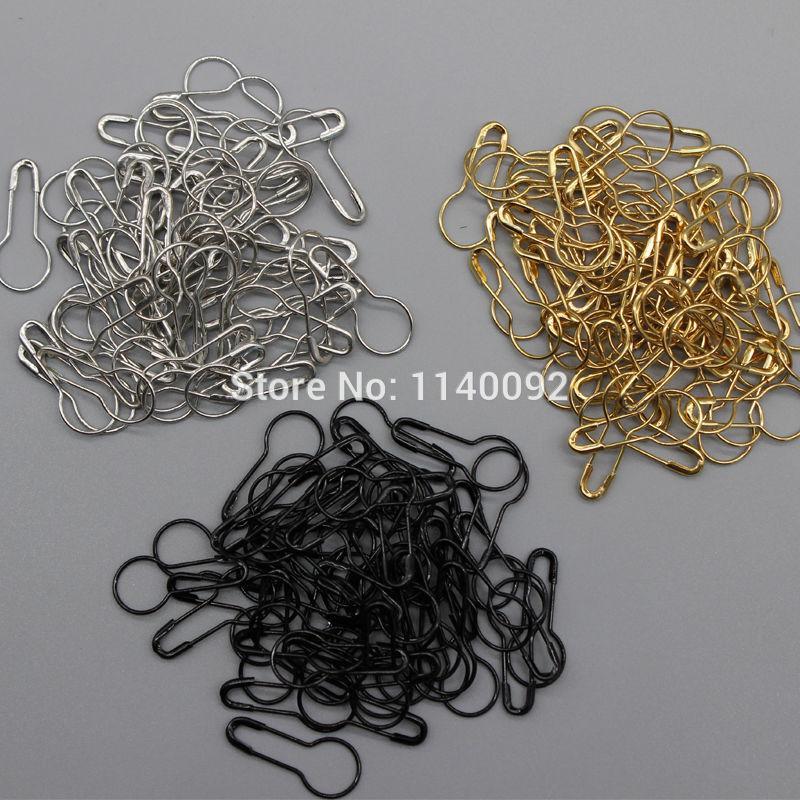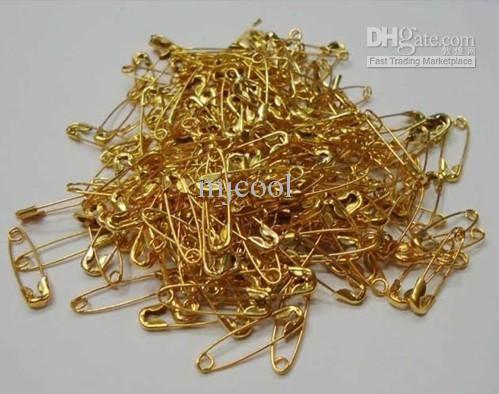The first image is the image on the left, the second image is the image on the right. Assess this claim about the two images: "An image shows only a pile of gold pins that are pear-shaped.". Correct or not? Answer yes or no. No. 